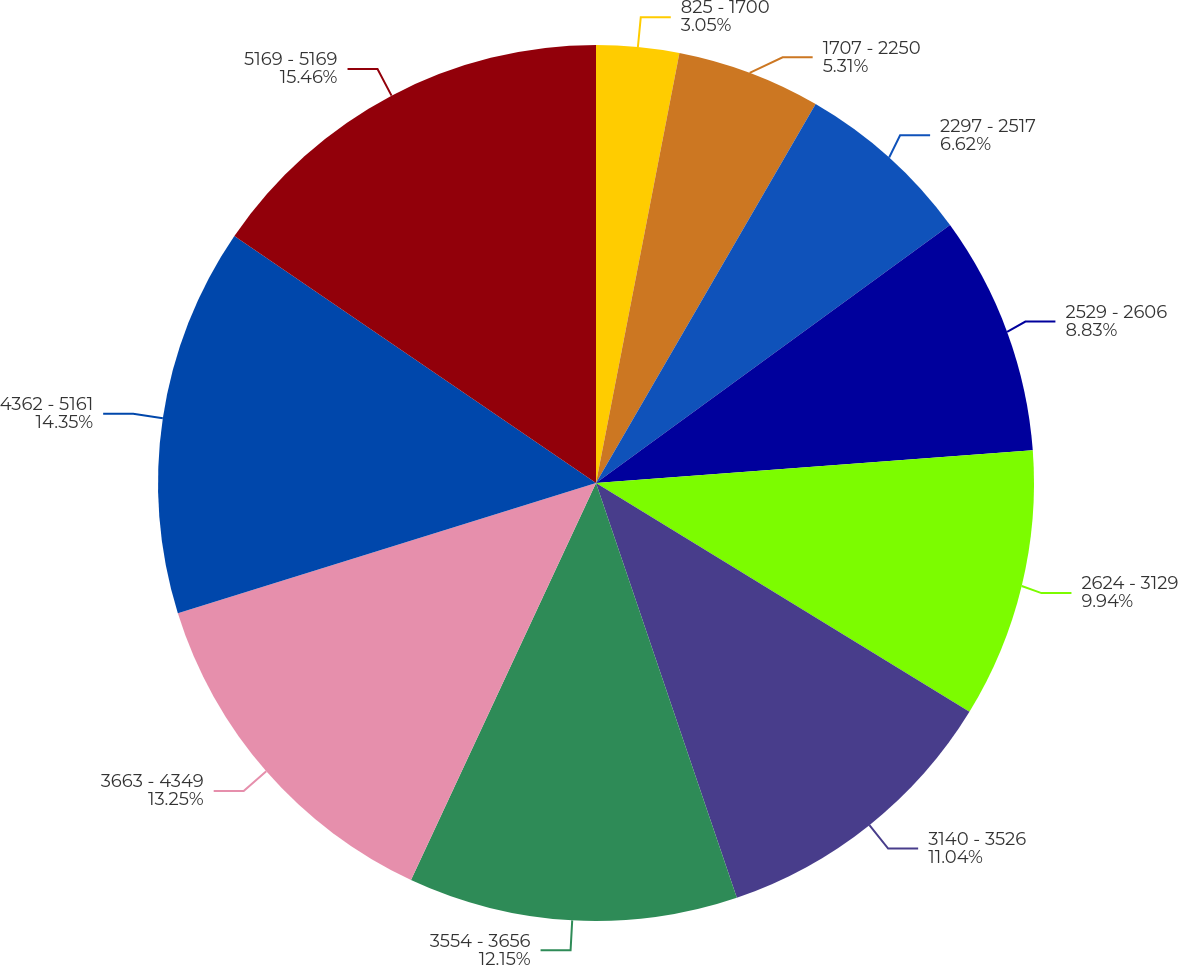Convert chart to OTSL. <chart><loc_0><loc_0><loc_500><loc_500><pie_chart><fcel>825 - 1700<fcel>1707 - 2250<fcel>2297 - 2517<fcel>2529 - 2606<fcel>2624 - 3129<fcel>3140 - 3526<fcel>3554 - 3656<fcel>3663 - 4349<fcel>4362 - 5161<fcel>5169 - 5169<nl><fcel>3.05%<fcel>5.31%<fcel>6.62%<fcel>8.83%<fcel>9.94%<fcel>11.04%<fcel>12.15%<fcel>13.25%<fcel>14.35%<fcel>15.46%<nl></chart> 